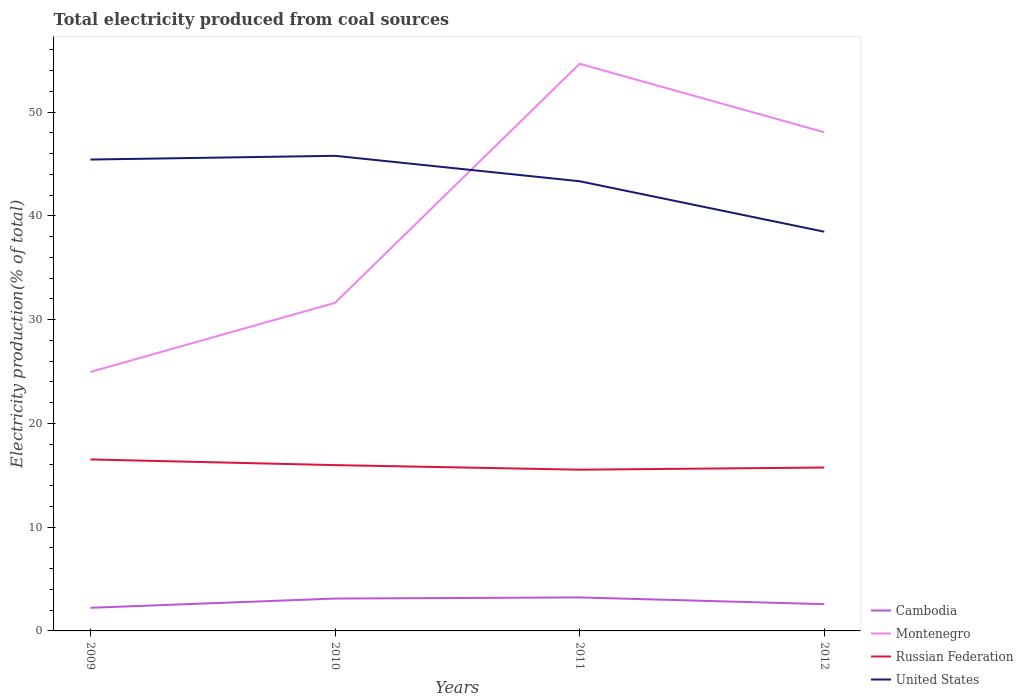Is the number of lines equal to the number of legend labels?
Offer a very short reply. Yes. Across all years, what is the maximum total electricity produced in Cambodia?
Make the answer very short. 2.23. What is the total total electricity produced in Montenegro in the graph?
Ensure brevity in your answer.  -6.66. What is the difference between the highest and the second highest total electricity produced in Montenegro?
Offer a very short reply. 29.7. What is the difference between the highest and the lowest total electricity produced in Russian Federation?
Your answer should be compact. 2. How many lines are there?
Give a very brief answer. 4. Are the values on the major ticks of Y-axis written in scientific E-notation?
Your response must be concise. No. Does the graph contain grids?
Ensure brevity in your answer.  No. Where does the legend appear in the graph?
Offer a terse response. Bottom right. How many legend labels are there?
Offer a very short reply. 4. What is the title of the graph?
Provide a short and direct response. Total electricity produced from coal sources. What is the Electricity production(% of total) in Cambodia in 2009?
Make the answer very short. 2.23. What is the Electricity production(% of total) in Montenegro in 2009?
Your answer should be compact. 24.96. What is the Electricity production(% of total) of Russian Federation in 2009?
Your response must be concise. 16.53. What is the Electricity production(% of total) of United States in 2009?
Keep it short and to the point. 45.44. What is the Electricity production(% of total) of Cambodia in 2010?
Make the answer very short. 3.12. What is the Electricity production(% of total) of Montenegro in 2010?
Give a very brief answer. 31.63. What is the Electricity production(% of total) in Russian Federation in 2010?
Offer a very short reply. 15.98. What is the Electricity production(% of total) of United States in 2010?
Provide a short and direct response. 45.8. What is the Electricity production(% of total) in Cambodia in 2011?
Ensure brevity in your answer.  3.23. What is the Electricity production(% of total) in Montenegro in 2011?
Provide a succinct answer. 54.67. What is the Electricity production(% of total) in Russian Federation in 2011?
Your answer should be very brief. 15.54. What is the Electricity production(% of total) of United States in 2011?
Offer a terse response. 43.35. What is the Electricity production(% of total) of Cambodia in 2012?
Provide a short and direct response. 2.58. What is the Electricity production(% of total) in Montenegro in 2012?
Provide a short and direct response. 48.07. What is the Electricity production(% of total) in Russian Federation in 2012?
Provide a short and direct response. 15.75. What is the Electricity production(% of total) in United States in 2012?
Provide a short and direct response. 38.48. Across all years, what is the maximum Electricity production(% of total) of Cambodia?
Provide a short and direct response. 3.23. Across all years, what is the maximum Electricity production(% of total) of Montenegro?
Provide a succinct answer. 54.67. Across all years, what is the maximum Electricity production(% of total) of Russian Federation?
Give a very brief answer. 16.53. Across all years, what is the maximum Electricity production(% of total) of United States?
Provide a short and direct response. 45.8. Across all years, what is the minimum Electricity production(% of total) in Cambodia?
Ensure brevity in your answer.  2.23. Across all years, what is the minimum Electricity production(% of total) in Montenegro?
Your response must be concise. 24.96. Across all years, what is the minimum Electricity production(% of total) in Russian Federation?
Provide a short and direct response. 15.54. Across all years, what is the minimum Electricity production(% of total) in United States?
Your answer should be compact. 38.48. What is the total Electricity production(% of total) of Cambodia in the graph?
Offer a terse response. 11.16. What is the total Electricity production(% of total) in Montenegro in the graph?
Your response must be concise. 159.32. What is the total Electricity production(% of total) in Russian Federation in the graph?
Your answer should be very brief. 63.8. What is the total Electricity production(% of total) of United States in the graph?
Your answer should be very brief. 173.06. What is the difference between the Electricity production(% of total) of Cambodia in 2009 and that in 2010?
Provide a short and direct response. -0.89. What is the difference between the Electricity production(% of total) in Montenegro in 2009 and that in 2010?
Provide a short and direct response. -6.66. What is the difference between the Electricity production(% of total) in Russian Federation in 2009 and that in 2010?
Give a very brief answer. 0.55. What is the difference between the Electricity production(% of total) in United States in 2009 and that in 2010?
Your answer should be compact. -0.36. What is the difference between the Electricity production(% of total) of Cambodia in 2009 and that in 2011?
Give a very brief answer. -1. What is the difference between the Electricity production(% of total) in Montenegro in 2009 and that in 2011?
Ensure brevity in your answer.  -29.7. What is the difference between the Electricity production(% of total) in Russian Federation in 2009 and that in 2011?
Your answer should be compact. 0.99. What is the difference between the Electricity production(% of total) in United States in 2009 and that in 2011?
Keep it short and to the point. 2.09. What is the difference between the Electricity production(% of total) of Cambodia in 2009 and that in 2012?
Make the answer very short. -0.35. What is the difference between the Electricity production(% of total) of Montenegro in 2009 and that in 2012?
Make the answer very short. -23.1. What is the difference between the Electricity production(% of total) of Russian Federation in 2009 and that in 2012?
Keep it short and to the point. 0.78. What is the difference between the Electricity production(% of total) of United States in 2009 and that in 2012?
Give a very brief answer. 6.96. What is the difference between the Electricity production(% of total) in Cambodia in 2010 and that in 2011?
Provide a succinct answer. -0.11. What is the difference between the Electricity production(% of total) in Montenegro in 2010 and that in 2011?
Keep it short and to the point. -23.04. What is the difference between the Electricity production(% of total) of Russian Federation in 2010 and that in 2011?
Give a very brief answer. 0.44. What is the difference between the Electricity production(% of total) of United States in 2010 and that in 2011?
Give a very brief answer. 2.45. What is the difference between the Electricity production(% of total) in Cambodia in 2010 and that in 2012?
Give a very brief answer. 0.54. What is the difference between the Electricity production(% of total) in Montenegro in 2010 and that in 2012?
Make the answer very short. -16.44. What is the difference between the Electricity production(% of total) in Russian Federation in 2010 and that in 2012?
Provide a succinct answer. 0.23. What is the difference between the Electricity production(% of total) in United States in 2010 and that in 2012?
Your answer should be very brief. 7.32. What is the difference between the Electricity production(% of total) in Cambodia in 2011 and that in 2012?
Offer a very short reply. 0.65. What is the difference between the Electricity production(% of total) of Montenegro in 2011 and that in 2012?
Keep it short and to the point. 6.6. What is the difference between the Electricity production(% of total) of Russian Federation in 2011 and that in 2012?
Keep it short and to the point. -0.21. What is the difference between the Electricity production(% of total) in United States in 2011 and that in 2012?
Give a very brief answer. 4.87. What is the difference between the Electricity production(% of total) in Cambodia in 2009 and the Electricity production(% of total) in Montenegro in 2010?
Provide a short and direct response. -29.4. What is the difference between the Electricity production(% of total) of Cambodia in 2009 and the Electricity production(% of total) of Russian Federation in 2010?
Your response must be concise. -13.75. What is the difference between the Electricity production(% of total) in Cambodia in 2009 and the Electricity production(% of total) in United States in 2010?
Offer a terse response. -43.57. What is the difference between the Electricity production(% of total) in Montenegro in 2009 and the Electricity production(% of total) in Russian Federation in 2010?
Your answer should be compact. 8.98. What is the difference between the Electricity production(% of total) in Montenegro in 2009 and the Electricity production(% of total) in United States in 2010?
Provide a short and direct response. -20.83. What is the difference between the Electricity production(% of total) of Russian Federation in 2009 and the Electricity production(% of total) of United States in 2010?
Your answer should be very brief. -29.27. What is the difference between the Electricity production(% of total) in Cambodia in 2009 and the Electricity production(% of total) in Montenegro in 2011?
Provide a short and direct response. -52.44. What is the difference between the Electricity production(% of total) in Cambodia in 2009 and the Electricity production(% of total) in Russian Federation in 2011?
Your response must be concise. -13.31. What is the difference between the Electricity production(% of total) in Cambodia in 2009 and the Electricity production(% of total) in United States in 2011?
Provide a short and direct response. -41.12. What is the difference between the Electricity production(% of total) of Montenegro in 2009 and the Electricity production(% of total) of Russian Federation in 2011?
Offer a terse response. 9.42. What is the difference between the Electricity production(% of total) in Montenegro in 2009 and the Electricity production(% of total) in United States in 2011?
Keep it short and to the point. -18.38. What is the difference between the Electricity production(% of total) of Russian Federation in 2009 and the Electricity production(% of total) of United States in 2011?
Your answer should be compact. -26.82. What is the difference between the Electricity production(% of total) of Cambodia in 2009 and the Electricity production(% of total) of Montenegro in 2012?
Offer a very short reply. -45.84. What is the difference between the Electricity production(% of total) of Cambodia in 2009 and the Electricity production(% of total) of Russian Federation in 2012?
Provide a succinct answer. -13.52. What is the difference between the Electricity production(% of total) in Cambodia in 2009 and the Electricity production(% of total) in United States in 2012?
Your answer should be compact. -36.25. What is the difference between the Electricity production(% of total) in Montenegro in 2009 and the Electricity production(% of total) in Russian Federation in 2012?
Provide a short and direct response. 9.21. What is the difference between the Electricity production(% of total) in Montenegro in 2009 and the Electricity production(% of total) in United States in 2012?
Ensure brevity in your answer.  -13.52. What is the difference between the Electricity production(% of total) of Russian Federation in 2009 and the Electricity production(% of total) of United States in 2012?
Provide a succinct answer. -21.95. What is the difference between the Electricity production(% of total) of Cambodia in 2010 and the Electricity production(% of total) of Montenegro in 2011?
Offer a terse response. -51.55. What is the difference between the Electricity production(% of total) of Cambodia in 2010 and the Electricity production(% of total) of Russian Federation in 2011?
Offer a very short reply. -12.42. What is the difference between the Electricity production(% of total) in Cambodia in 2010 and the Electricity production(% of total) in United States in 2011?
Your answer should be very brief. -40.23. What is the difference between the Electricity production(% of total) of Montenegro in 2010 and the Electricity production(% of total) of Russian Federation in 2011?
Your answer should be compact. 16.08. What is the difference between the Electricity production(% of total) in Montenegro in 2010 and the Electricity production(% of total) in United States in 2011?
Give a very brief answer. -11.72. What is the difference between the Electricity production(% of total) in Russian Federation in 2010 and the Electricity production(% of total) in United States in 2011?
Make the answer very short. -27.36. What is the difference between the Electricity production(% of total) in Cambodia in 2010 and the Electricity production(% of total) in Montenegro in 2012?
Make the answer very short. -44.95. What is the difference between the Electricity production(% of total) in Cambodia in 2010 and the Electricity production(% of total) in Russian Federation in 2012?
Your response must be concise. -12.63. What is the difference between the Electricity production(% of total) of Cambodia in 2010 and the Electricity production(% of total) of United States in 2012?
Provide a short and direct response. -35.36. What is the difference between the Electricity production(% of total) of Montenegro in 2010 and the Electricity production(% of total) of Russian Federation in 2012?
Make the answer very short. 15.88. What is the difference between the Electricity production(% of total) of Montenegro in 2010 and the Electricity production(% of total) of United States in 2012?
Keep it short and to the point. -6.85. What is the difference between the Electricity production(% of total) in Russian Federation in 2010 and the Electricity production(% of total) in United States in 2012?
Ensure brevity in your answer.  -22.5. What is the difference between the Electricity production(% of total) of Cambodia in 2011 and the Electricity production(% of total) of Montenegro in 2012?
Keep it short and to the point. -44.84. What is the difference between the Electricity production(% of total) in Cambodia in 2011 and the Electricity production(% of total) in Russian Federation in 2012?
Provide a succinct answer. -12.52. What is the difference between the Electricity production(% of total) in Cambodia in 2011 and the Electricity production(% of total) in United States in 2012?
Keep it short and to the point. -35.25. What is the difference between the Electricity production(% of total) in Montenegro in 2011 and the Electricity production(% of total) in Russian Federation in 2012?
Make the answer very short. 38.92. What is the difference between the Electricity production(% of total) of Montenegro in 2011 and the Electricity production(% of total) of United States in 2012?
Your answer should be very brief. 16.19. What is the difference between the Electricity production(% of total) in Russian Federation in 2011 and the Electricity production(% of total) in United States in 2012?
Your answer should be very brief. -22.94. What is the average Electricity production(% of total) in Cambodia per year?
Offer a terse response. 2.79. What is the average Electricity production(% of total) in Montenegro per year?
Your answer should be compact. 39.83. What is the average Electricity production(% of total) in Russian Federation per year?
Your answer should be very brief. 15.95. What is the average Electricity production(% of total) of United States per year?
Give a very brief answer. 43.27. In the year 2009, what is the difference between the Electricity production(% of total) in Cambodia and Electricity production(% of total) in Montenegro?
Make the answer very short. -22.73. In the year 2009, what is the difference between the Electricity production(% of total) in Cambodia and Electricity production(% of total) in Russian Federation?
Make the answer very short. -14.3. In the year 2009, what is the difference between the Electricity production(% of total) of Cambodia and Electricity production(% of total) of United States?
Offer a terse response. -43.21. In the year 2009, what is the difference between the Electricity production(% of total) of Montenegro and Electricity production(% of total) of Russian Federation?
Give a very brief answer. 8.43. In the year 2009, what is the difference between the Electricity production(% of total) in Montenegro and Electricity production(% of total) in United States?
Ensure brevity in your answer.  -20.47. In the year 2009, what is the difference between the Electricity production(% of total) in Russian Federation and Electricity production(% of total) in United States?
Your answer should be very brief. -28.91. In the year 2010, what is the difference between the Electricity production(% of total) of Cambodia and Electricity production(% of total) of Montenegro?
Offer a very short reply. -28.51. In the year 2010, what is the difference between the Electricity production(% of total) in Cambodia and Electricity production(% of total) in Russian Federation?
Your answer should be very brief. -12.86. In the year 2010, what is the difference between the Electricity production(% of total) in Cambodia and Electricity production(% of total) in United States?
Offer a terse response. -42.68. In the year 2010, what is the difference between the Electricity production(% of total) of Montenegro and Electricity production(% of total) of Russian Federation?
Offer a very short reply. 15.64. In the year 2010, what is the difference between the Electricity production(% of total) of Montenegro and Electricity production(% of total) of United States?
Keep it short and to the point. -14.17. In the year 2010, what is the difference between the Electricity production(% of total) in Russian Federation and Electricity production(% of total) in United States?
Offer a terse response. -29.81. In the year 2011, what is the difference between the Electricity production(% of total) of Cambodia and Electricity production(% of total) of Montenegro?
Ensure brevity in your answer.  -51.44. In the year 2011, what is the difference between the Electricity production(% of total) in Cambodia and Electricity production(% of total) in Russian Federation?
Your answer should be very brief. -12.31. In the year 2011, what is the difference between the Electricity production(% of total) of Cambodia and Electricity production(% of total) of United States?
Keep it short and to the point. -40.12. In the year 2011, what is the difference between the Electricity production(% of total) in Montenegro and Electricity production(% of total) in Russian Federation?
Offer a very short reply. 39.13. In the year 2011, what is the difference between the Electricity production(% of total) of Montenegro and Electricity production(% of total) of United States?
Offer a very short reply. 11.32. In the year 2011, what is the difference between the Electricity production(% of total) in Russian Federation and Electricity production(% of total) in United States?
Provide a succinct answer. -27.8. In the year 2012, what is the difference between the Electricity production(% of total) in Cambodia and Electricity production(% of total) in Montenegro?
Your response must be concise. -45.49. In the year 2012, what is the difference between the Electricity production(% of total) in Cambodia and Electricity production(% of total) in Russian Federation?
Your answer should be compact. -13.17. In the year 2012, what is the difference between the Electricity production(% of total) in Cambodia and Electricity production(% of total) in United States?
Provide a short and direct response. -35.9. In the year 2012, what is the difference between the Electricity production(% of total) in Montenegro and Electricity production(% of total) in Russian Federation?
Provide a short and direct response. 32.32. In the year 2012, what is the difference between the Electricity production(% of total) in Montenegro and Electricity production(% of total) in United States?
Keep it short and to the point. 9.59. In the year 2012, what is the difference between the Electricity production(% of total) of Russian Federation and Electricity production(% of total) of United States?
Offer a terse response. -22.73. What is the ratio of the Electricity production(% of total) of Cambodia in 2009 to that in 2010?
Give a very brief answer. 0.71. What is the ratio of the Electricity production(% of total) in Montenegro in 2009 to that in 2010?
Your response must be concise. 0.79. What is the ratio of the Electricity production(% of total) of Russian Federation in 2009 to that in 2010?
Your answer should be very brief. 1.03. What is the ratio of the Electricity production(% of total) in United States in 2009 to that in 2010?
Provide a short and direct response. 0.99. What is the ratio of the Electricity production(% of total) of Cambodia in 2009 to that in 2011?
Offer a terse response. 0.69. What is the ratio of the Electricity production(% of total) in Montenegro in 2009 to that in 2011?
Provide a succinct answer. 0.46. What is the ratio of the Electricity production(% of total) in Russian Federation in 2009 to that in 2011?
Your answer should be compact. 1.06. What is the ratio of the Electricity production(% of total) of United States in 2009 to that in 2011?
Give a very brief answer. 1.05. What is the ratio of the Electricity production(% of total) of Cambodia in 2009 to that in 2012?
Provide a succinct answer. 0.86. What is the ratio of the Electricity production(% of total) in Montenegro in 2009 to that in 2012?
Your answer should be compact. 0.52. What is the ratio of the Electricity production(% of total) of Russian Federation in 2009 to that in 2012?
Keep it short and to the point. 1.05. What is the ratio of the Electricity production(% of total) in United States in 2009 to that in 2012?
Offer a terse response. 1.18. What is the ratio of the Electricity production(% of total) in Cambodia in 2010 to that in 2011?
Give a very brief answer. 0.97. What is the ratio of the Electricity production(% of total) of Montenegro in 2010 to that in 2011?
Your answer should be very brief. 0.58. What is the ratio of the Electricity production(% of total) of Russian Federation in 2010 to that in 2011?
Provide a succinct answer. 1.03. What is the ratio of the Electricity production(% of total) in United States in 2010 to that in 2011?
Your answer should be compact. 1.06. What is the ratio of the Electricity production(% of total) of Cambodia in 2010 to that in 2012?
Your response must be concise. 1.21. What is the ratio of the Electricity production(% of total) of Montenegro in 2010 to that in 2012?
Ensure brevity in your answer.  0.66. What is the ratio of the Electricity production(% of total) of Russian Federation in 2010 to that in 2012?
Keep it short and to the point. 1.01. What is the ratio of the Electricity production(% of total) in United States in 2010 to that in 2012?
Your answer should be very brief. 1.19. What is the ratio of the Electricity production(% of total) of Cambodia in 2011 to that in 2012?
Make the answer very short. 1.25. What is the ratio of the Electricity production(% of total) of Montenegro in 2011 to that in 2012?
Provide a short and direct response. 1.14. What is the ratio of the Electricity production(% of total) of United States in 2011 to that in 2012?
Provide a short and direct response. 1.13. What is the difference between the highest and the second highest Electricity production(% of total) of Cambodia?
Offer a terse response. 0.11. What is the difference between the highest and the second highest Electricity production(% of total) in Montenegro?
Make the answer very short. 6.6. What is the difference between the highest and the second highest Electricity production(% of total) in Russian Federation?
Offer a very short reply. 0.55. What is the difference between the highest and the second highest Electricity production(% of total) in United States?
Provide a succinct answer. 0.36. What is the difference between the highest and the lowest Electricity production(% of total) of Cambodia?
Provide a succinct answer. 1. What is the difference between the highest and the lowest Electricity production(% of total) of Montenegro?
Your answer should be compact. 29.7. What is the difference between the highest and the lowest Electricity production(% of total) of Russian Federation?
Keep it short and to the point. 0.99. What is the difference between the highest and the lowest Electricity production(% of total) in United States?
Provide a succinct answer. 7.32. 